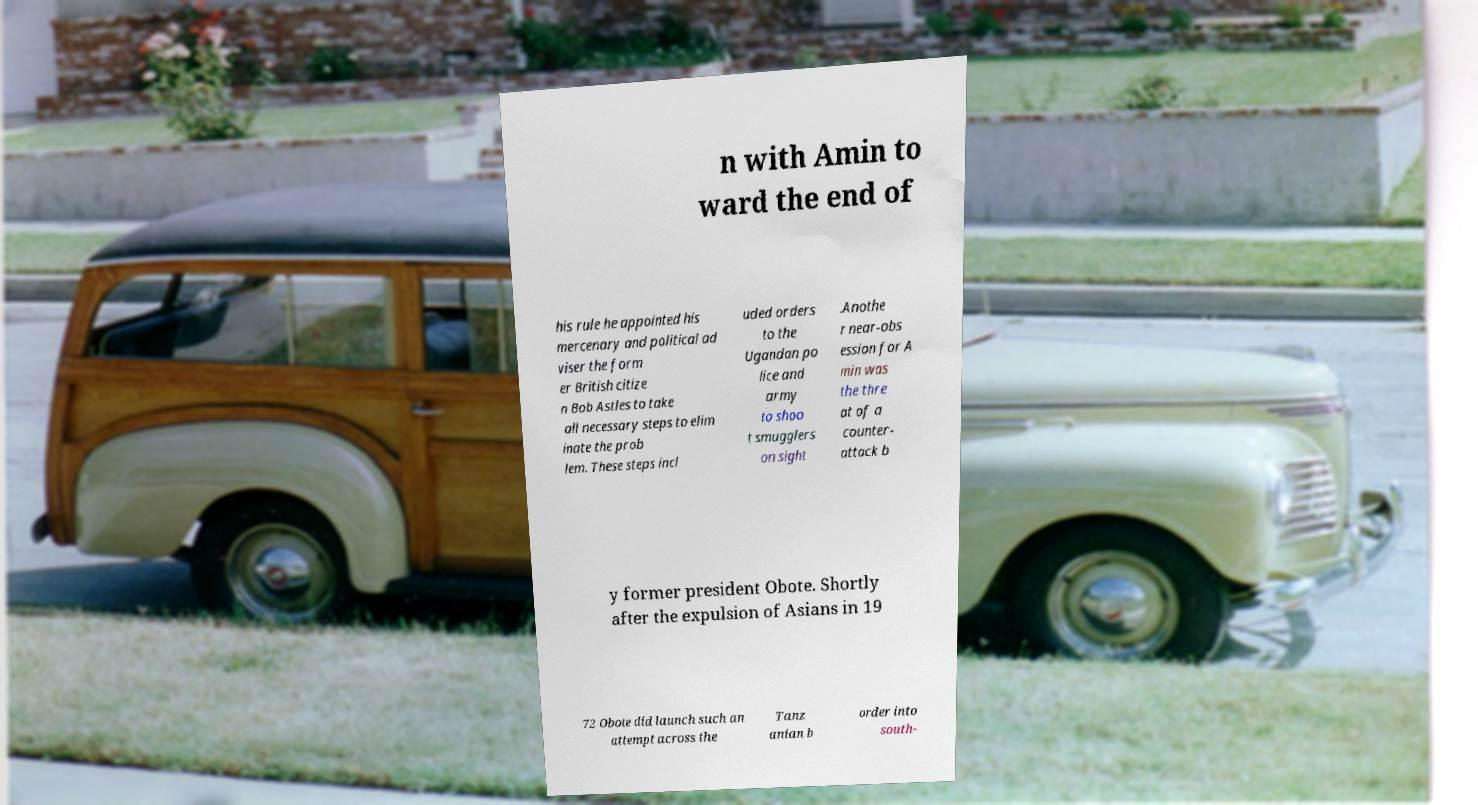Can you read and provide the text displayed in the image?This photo seems to have some interesting text. Can you extract and type it out for me? n with Amin to ward the end of his rule he appointed his mercenary and political ad viser the form er British citize n Bob Astles to take all necessary steps to elim inate the prob lem. These steps incl uded orders to the Ugandan po lice and army to shoo t smugglers on sight .Anothe r near-obs ession for A min was the thre at of a counter- attack b y former president Obote. Shortly after the expulsion of Asians in 19 72 Obote did launch such an attempt across the Tanz anian b order into south- 